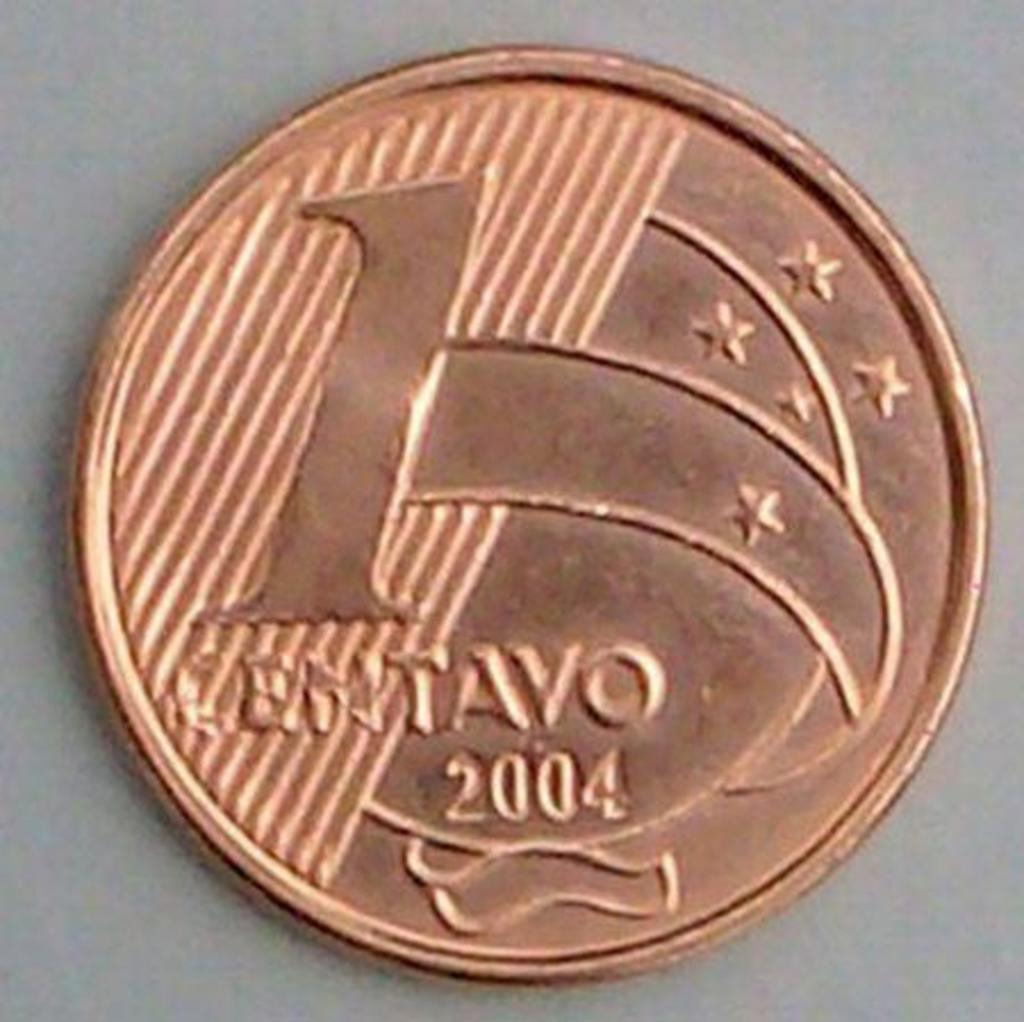What year is on the coin?
Your response must be concise. 2004. This is daller kain?
Your answer should be compact. No. 